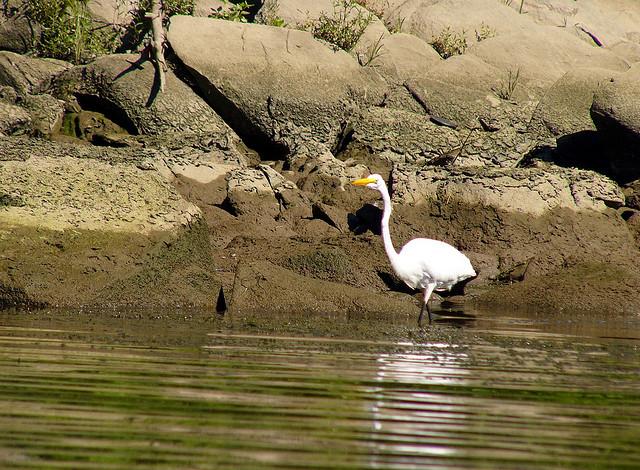What is the shore made out of?
Answer briefly. Rock. How many animal are there?
Be succinct. 1. Is the bird eating something?
Short answer required. No. Where is the bird?
Give a very brief answer. Water. Can you see the birds feet?
Concise answer only. No. 